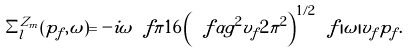Convert formula to latex. <formula><loc_0><loc_0><loc_500><loc_500>\Sigma ^ { Z _ { m } } _ { l } ( p _ { f } , \omega ) = - i \omega \ f { \pi } { 1 6 } \left ( \ f { \alpha g ^ { 2 } v _ { f } } { 2 \pi ^ { 2 } } \right ) ^ { 1 / 2 } \ f { | \omega | } { v _ { f } p _ { f } } .</formula> 